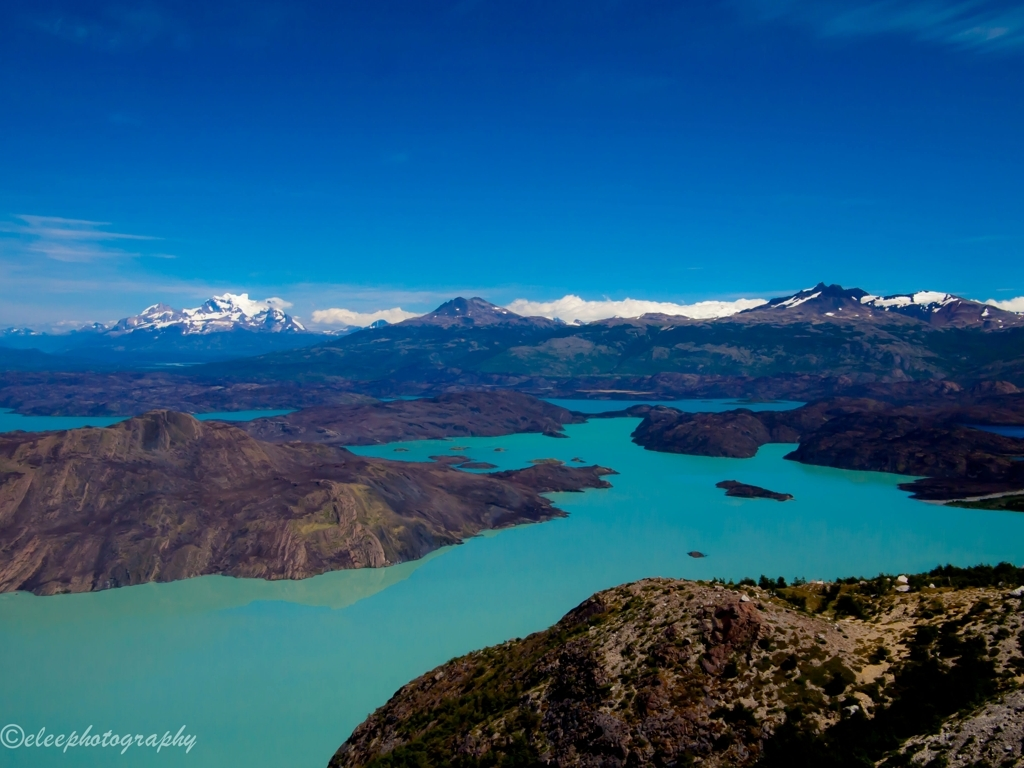What time of day and season does this image likely depict, and how can you tell? The image appears to be taken on a bright, clear day, suggesting a midday timeframe when the sun is high and the light is evenly distributed. Judging by the lack of ice on the lake and the snow restricted to the mountaintops, it's likely a late spring or summer season. The skies are mostly clear with just a few wispy clouds, and the vegetation doesn't show signs of autumnal colors or wintry dormancy. 